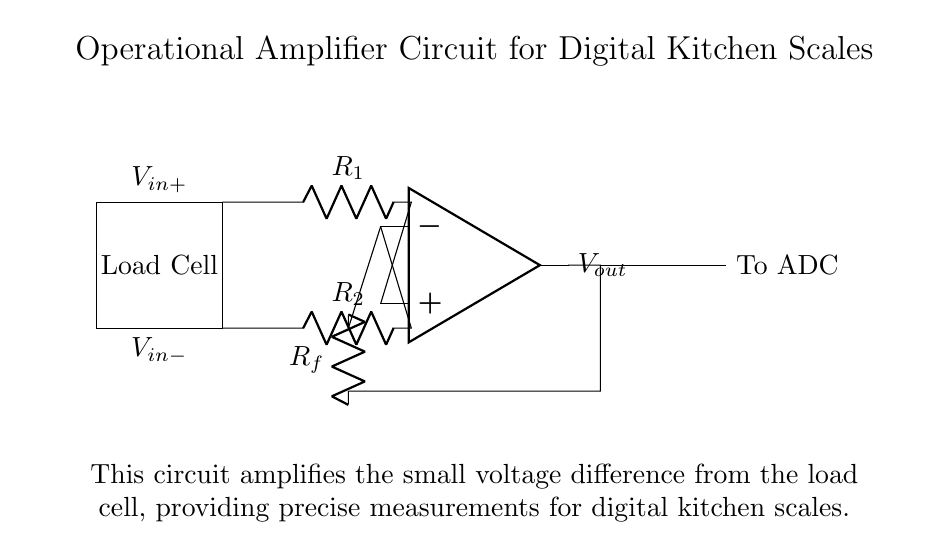What is the function of the load cell in this circuit? The load cell is used to convert the mechanical force (weight) into a small voltage which can be processed by the operational amplifier.
Answer: Convert weight to voltage What type of operational amplifier configuration is used here? The circuit is a non-inverting amplifier because the input voltage to the non-inverting terminal is greater than that at the inverting terminal.
Answer: Non-inverting What is the role of the resistor R_f? Resistor R_f is a feedback resistor that sets the gain of the operational amplifier, allowing it to amplify the signal from the load cell.
Answer: Set gain What is the relationship between V_in+ and V_in-? V_in+ must be greater than V_in- for the operational amplifier to output a positive voltage, indicating the load cell is under load.
Answer: V_in+ > V_in- What would happen if R_f is increased? Increasing R_f will increase the gain of the operational amplifier, resulting in a larger output voltage for the same input signal from the load cell.
Answer: Output voltage increases What is the output of this circuit connected to? The output of the circuit is connected to an Analog to Digital Converter (ADC) which converts the amplified analog voltage into a digital signal for processing.
Answer: To ADC 